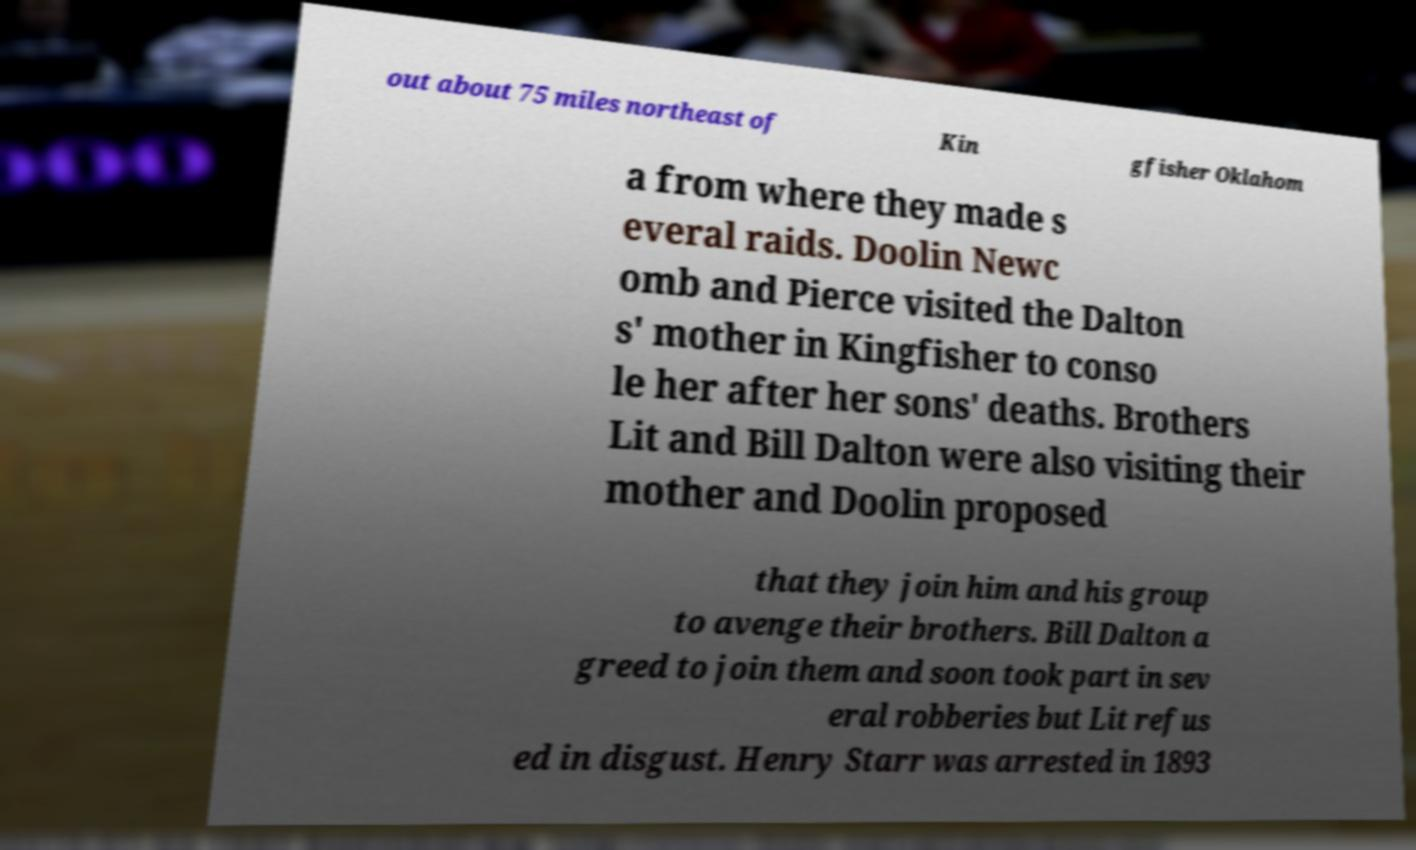Could you extract and type out the text from this image? out about 75 miles northeast of Kin gfisher Oklahom a from where they made s everal raids. Doolin Newc omb and Pierce visited the Dalton s' mother in Kingfisher to conso le her after her sons' deaths. Brothers Lit and Bill Dalton were also visiting their mother and Doolin proposed that they join him and his group to avenge their brothers. Bill Dalton a greed to join them and soon took part in sev eral robberies but Lit refus ed in disgust. Henry Starr was arrested in 1893 